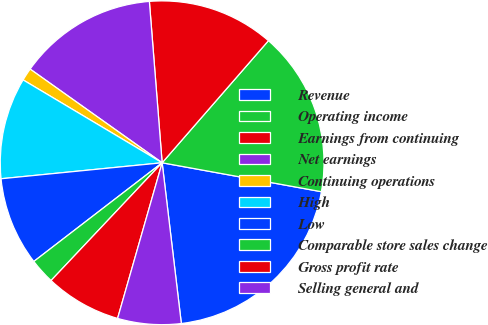<chart> <loc_0><loc_0><loc_500><loc_500><pie_chart><fcel>Revenue<fcel>Operating income<fcel>Earnings from continuing<fcel>Net earnings<fcel>Continuing operations<fcel>High<fcel>Low<fcel>Comparable store sales change<fcel>Gross profit rate<fcel>Selling general and<nl><fcel>20.25%<fcel>16.46%<fcel>12.66%<fcel>13.92%<fcel>1.27%<fcel>10.13%<fcel>8.86%<fcel>2.53%<fcel>7.6%<fcel>6.33%<nl></chart> 